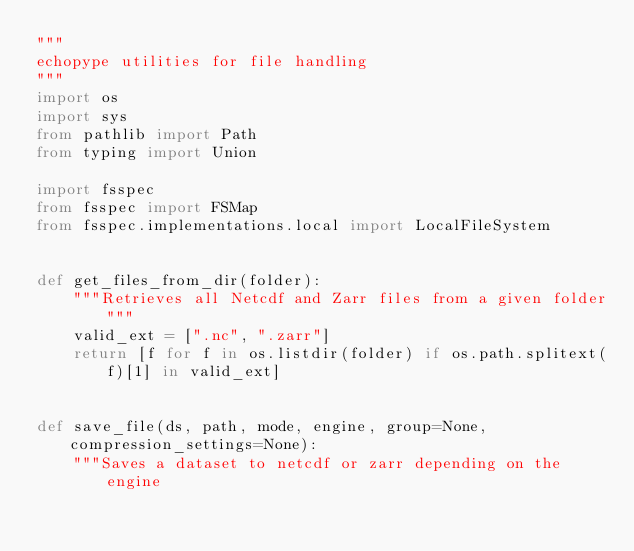<code> <loc_0><loc_0><loc_500><loc_500><_Python_>"""
echopype utilities for file handling
"""
import os
import sys
from pathlib import Path
from typing import Union

import fsspec
from fsspec import FSMap
from fsspec.implementations.local import LocalFileSystem


def get_files_from_dir(folder):
    """Retrieves all Netcdf and Zarr files from a given folder"""
    valid_ext = [".nc", ".zarr"]
    return [f for f in os.listdir(folder) if os.path.splitext(f)[1] in valid_ext]


def save_file(ds, path, mode, engine, group=None, compression_settings=None):
    """Saves a dataset to netcdf or zarr depending on the engine</code> 